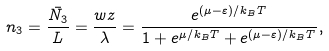<formula> <loc_0><loc_0><loc_500><loc_500>n _ { 3 } = \frac { \bar { N _ { 3 } } } { L } = \frac { w z } { \lambda } = \frac { e ^ { ( \mu - \varepsilon ) / k _ { B } T } } { 1 + e ^ { \mu / k _ { B } T } + e ^ { ( \mu - \varepsilon ) / k _ { B } T } } ,</formula> 